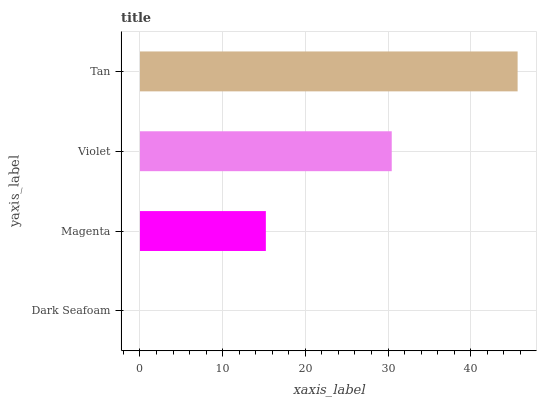Is Dark Seafoam the minimum?
Answer yes or no. Yes. Is Tan the maximum?
Answer yes or no. Yes. Is Magenta the minimum?
Answer yes or no. No. Is Magenta the maximum?
Answer yes or no. No. Is Magenta greater than Dark Seafoam?
Answer yes or no. Yes. Is Dark Seafoam less than Magenta?
Answer yes or no. Yes. Is Dark Seafoam greater than Magenta?
Answer yes or no. No. Is Magenta less than Dark Seafoam?
Answer yes or no. No. Is Violet the high median?
Answer yes or no. Yes. Is Magenta the low median?
Answer yes or no. Yes. Is Tan the high median?
Answer yes or no. No. Is Tan the low median?
Answer yes or no. No. 